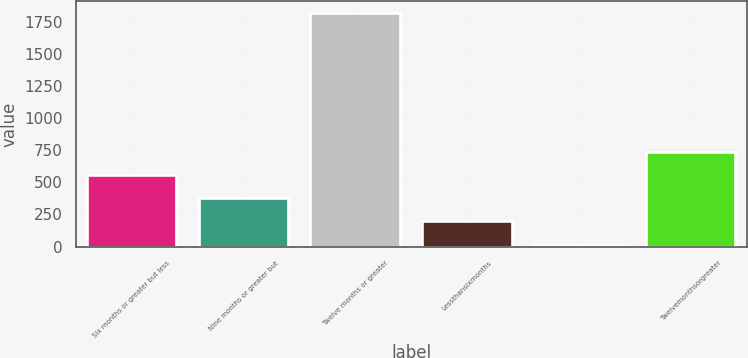Convert chart. <chart><loc_0><loc_0><loc_500><loc_500><bar_chart><fcel>Six months or greater but less<fcel>Nine months or greater but<fcel>Twelve months or greater<fcel>Lessthansixmonths<fcel>Unnamed: 4<fcel>Twelvemonthsorgreater<nl><fcel>557.5<fcel>377<fcel>1821<fcel>196.5<fcel>16<fcel>738<nl></chart> 